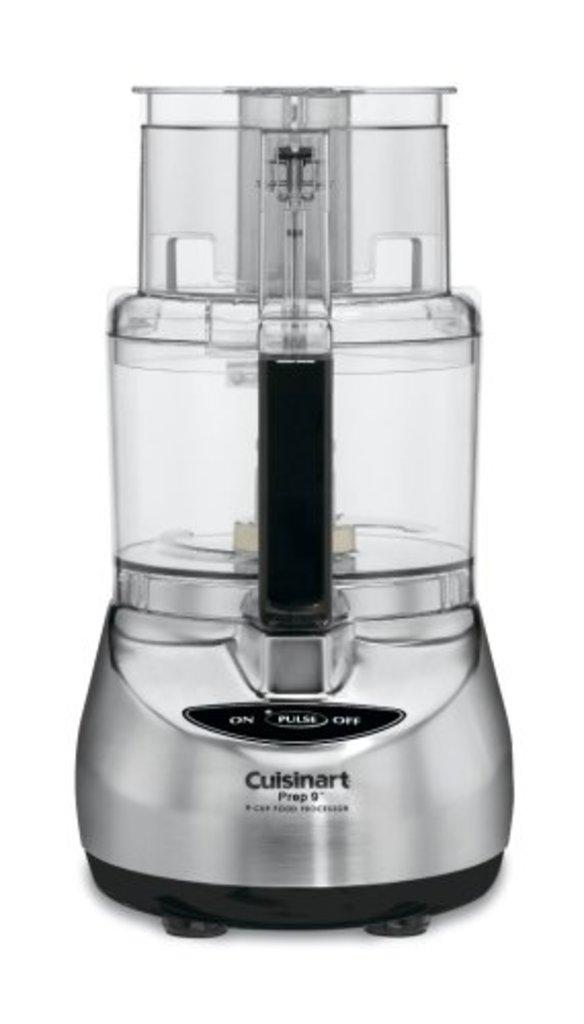<image>
Describe the image concisely. A Cuisinart Prep 9" silver food processor that has the words on, off and pulse on it. 